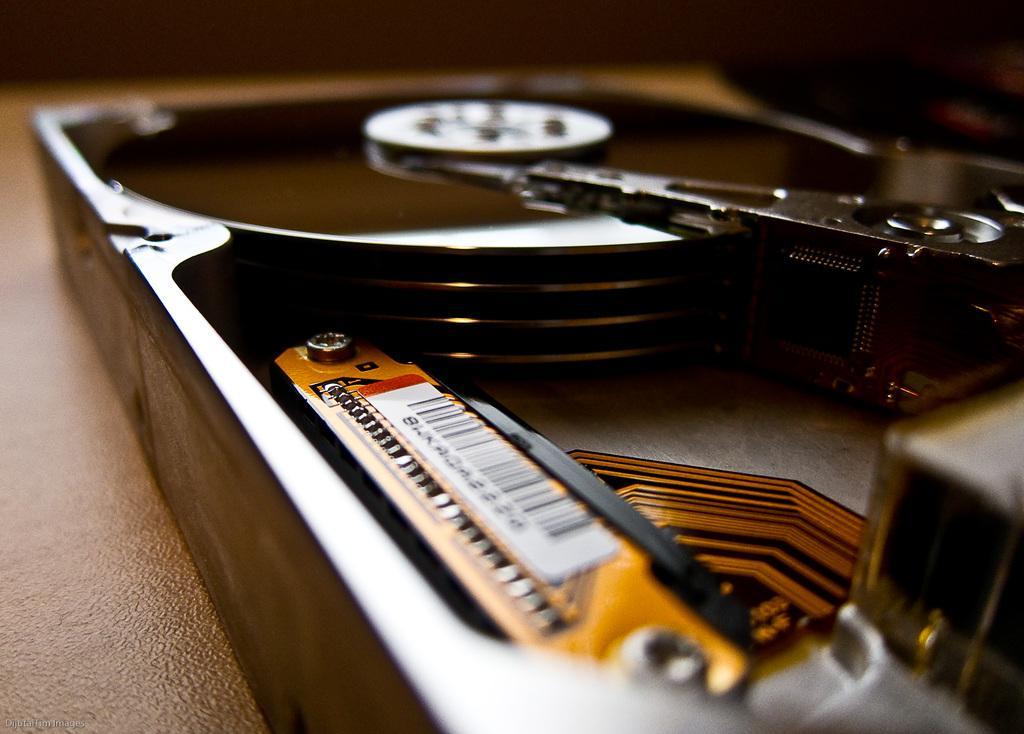Can you describe this image briefly? In this image I can see there is a music player on the table. 